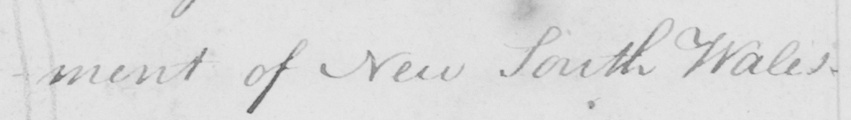Can you tell me what this handwritten text says? -ment of New South Wales . 